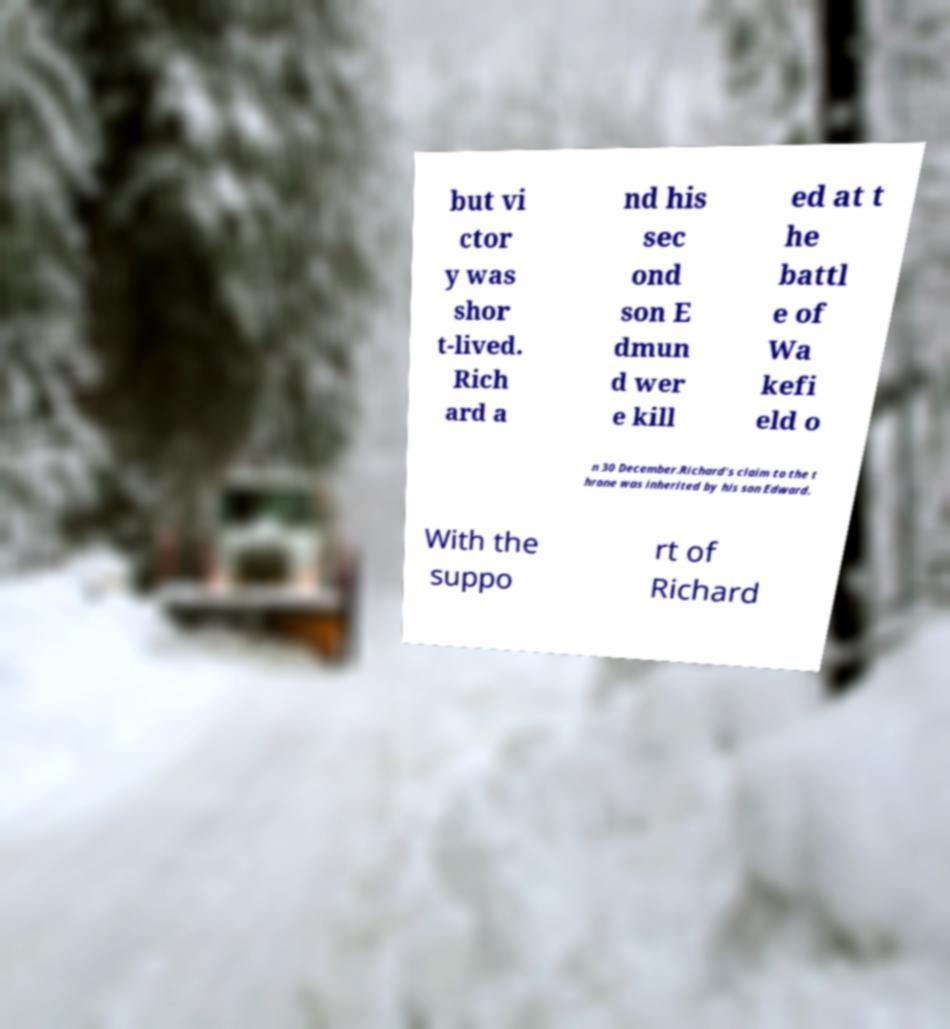What messages or text are displayed in this image? I need them in a readable, typed format. but vi ctor y was shor t-lived. Rich ard a nd his sec ond son E dmun d wer e kill ed at t he battl e of Wa kefi eld o n 30 December.Richard's claim to the t hrone was inherited by his son Edward. With the suppo rt of Richard 